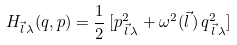<formula> <loc_0><loc_0><loc_500><loc_500>H _ { \vec { l } \, \lambda } ( q , p ) = \frac { 1 } { 2 } \, [ p _ { \, \vec { l } \, \lambda } ^ { 2 } + \omega ^ { 2 } ( \vec { l } \, ) \, q _ { \, \vec { l } \, \lambda } ^ { 2 } ]</formula> 